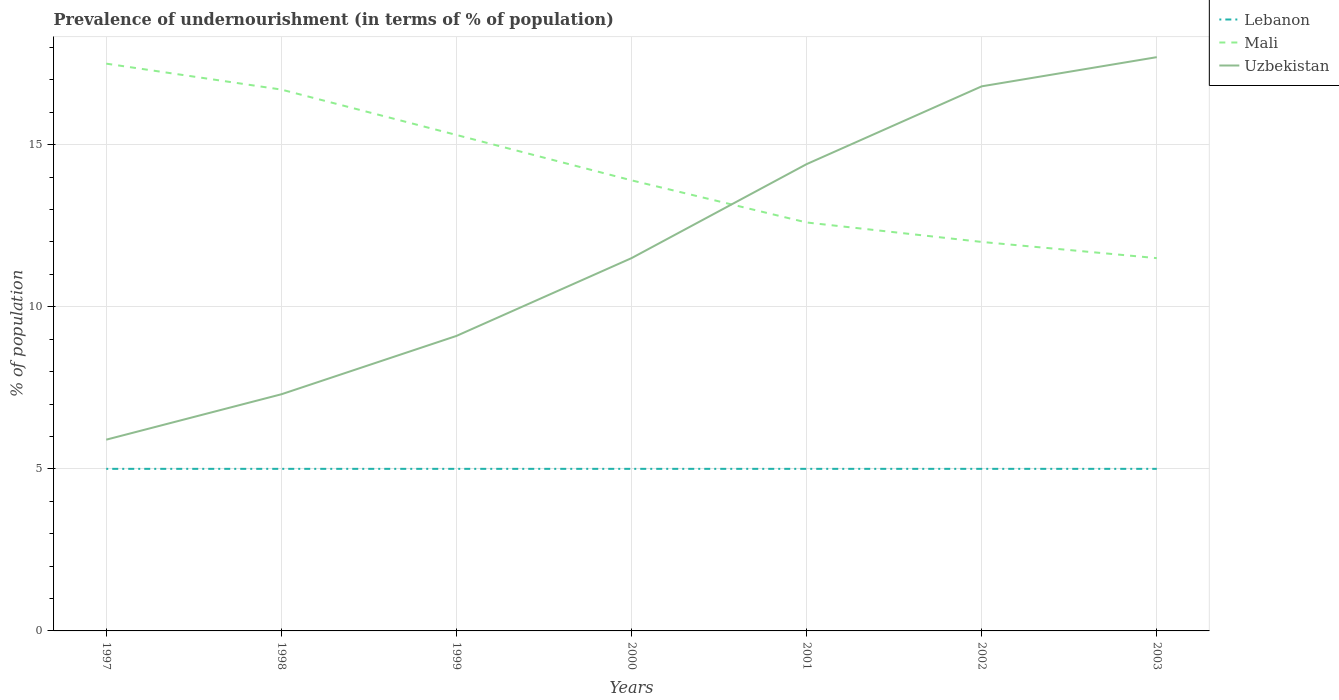How many different coloured lines are there?
Give a very brief answer. 3. Does the line corresponding to Uzbekistan intersect with the line corresponding to Mali?
Keep it short and to the point. Yes. Across all years, what is the maximum percentage of undernourished population in Uzbekistan?
Provide a short and direct response. 5.9. In which year was the percentage of undernourished population in Uzbekistan maximum?
Give a very brief answer. 1997. What is the total percentage of undernourished population in Mali in the graph?
Your answer should be compact. 2.7. Is the percentage of undernourished population in Mali strictly greater than the percentage of undernourished population in Uzbekistan over the years?
Give a very brief answer. No. How many lines are there?
Ensure brevity in your answer.  3. What is the difference between two consecutive major ticks on the Y-axis?
Offer a terse response. 5. Does the graph contain any zero values?
Offer a very short reply. No. How many legend labels are there?
Your answer should be very brief. 3. How are the legend labels stacked?
Provide a short and direct response. Vertical. What is the title of the graph?
Offer a terse response. Prevalence of undernourishment (in terms of % of population). Does "Cyprus" appear as one of the legend labels in the graph?
Offer a very short reply. No. What is the label or title of the Y-axis?
Offer a very short reply. % of population. What is the % of population of Mali in 1997?
Your response must be concise. 17.5. What is the % of population in Uzbekistan in 1997?
Offer a terse response. 5.9. What is the % of population of Mali in 1998?
Your answer should be very brief. 16.7. What is the % of population in Uzbekistan in 1998?
Keep it short and to the point. 7.3. What is the % of population in Lebanon in 1999?
Offer a very short reply. 5. What is the % of population of Mali in 1999?
Provide a short and direct response. 15.3. What is the % of population in Uzbekistan in 1999?
Offer a very short reply. 9.1. What is the % of population of Lebanon in 2000?
Provide a short and direct response. 5. What is the % of population of Mali in 2000?
Ensure brevity in your answer.  13.9. What is the % of population of Lebanon in 2001?
Your answer should be compact. 5. What is the % of population of Uzbekistan in 2001?
Your response must be concise. 14.4. What is the % of population in Uzbekistan in 2002?
Give a very brief answer. 16.8. What is the % of population of Lebanon in 2003?
Ensure brevity in your answer.  5. What is the % of population in Mali in 2003?
Offer a terse response. 11.5. What is the % of population in Uzbekistan in 2003?
Offer a very short reply. 17.7. Across all years, what is the maximum % of population in Lebanon?
Provide a succinct answer. 5. Across all years, what is the maximum % of population of Mali?
Provide a succinct answer. 17.5. Across all years, what is the minimum % of population of Lebanon?
Offer a very short reply. 5. Across all years, what is the minimum % of population in Mali?
Offer a very short reply. 11.5. Across all years, what is the minimum % of population of Uzbekistan?
Keep it short and to the point. 5.9. What is the total % of population of Mali in the graph?
Your response must be concise. 99.5. What is the total % of population of Uzbekistan in the graph?
Offer a terse response. 82.7. What is the difference between the % of population of Mali in 1997 and that in 1998?
Your answer should be compact. 0.8. What is the difference between the % of population in Mali in 1997 and that in 1999?
Your response must be concise. 2.2. What is the difference between the % of population in Uzbekistan in 1997 and that in 1999?
Your answer should be compact. -3.2. What is the difference between the % of population in Uzbekistan in 1997 and that in 2000?
Provide a succinct answer. -5.6. What is the difference between the % of population of Lebanon in 1997 and that in 2001?
Provide a short and direct response. 0. What is the difference between the % of population of Mali in 1997 and that in 2001?
Offer a terse response. 4.9. What is the difference between the % of population of Uzbekistan in 1997 and that in 2001?
Offer a terse response. -8.5. What is the difference between the % of population in Lebanon in 1997 and that in 2002?
Offer a very short reply. 0. What is the difference between the % of population of Mali in 1997 and that in 2002?
Ensure brevity in your answer.  5.5. What is the difference between the % of population of Uzbekistan in 1997 and that in 2002?
Provide a succinct answer. -10.9. What is the difference between the % of population in Lebanon in 1997 and that in 2003?
Your answer should be compact. 0. What is the difference between the % of population of Mali in 1997 and that in 2003?
Your answer should be very brief. 6. What is the difference between the % of population of Uzbekistan in 1997 and that in 2003?
Your response must be concise. -11.8. What is the difference between the % of population of Lebanon in 1998 and that in 1999?
Make the answer very short. 0. What is the difference between the % of population in Lebanon in 1998 and that in 2001?
Give a very brief answer. 0. What is the difference between the % of population of Mali in 1998 and that in 2001?
Your answer should be very brief. 4.1. What is the difference between the % of population in Mali in 1999 and that in 2000?
Your answer should be very brief. 1.4. What is the difference between the % of population of Uzbekistan in 1999 and that in 2000?
Offer a very short reply. -2.4. What is the difference between the % of population in Mali in 1999 and that in 2002?
Keep it short and to the point. 3.3. What is the difference between the % of population of Uzbekistan in 1999 and that in 2002?
Provide a short and direct response. -7.7. What is the difference between the % of population in Mali in 2000 and that in 2001?
Your answer should be very brief. 1.3. What is the difference between the % of population of Uzbekistan in 2000 and that in 2001?
Keep it short and to the point. -2.9. What is the difference between the % of population of Lebanon in 2000 and that in 2002?
Keep it short and to the point. 0. What is the difference between the % of population in Mali in 2000 and that in 2002?
Make the answer very short. 1.9. What is the difference between the % of population of Uzbekistan in 2000 and that in 2002?
Your answer should be compact. -5.3. What is the difference between the % of population in Mali in 2001 and that in 2002?
Provide a short and direct response. 0.6. What is the difference between the % of population of Lebanon in 2001 and that in 2003?
Give a very brief answer. 0. What is the difference between the % of population in Uzbekistan in 2001 and that in 2003?
Offer a terse response. -3.3. What is the difference between the % of population of Lebanon in 2002 and that in 2003?
Make the answer very short. 0. What is the difference between the % of population of Mali in 2002 and that in 2003?
Your answer should be compact. 0.5. What is the difference between the % of population of Uzbekistan in 2002 and that in 2003?
Your answer should be compact. -0.9. What is the difference between the % of population of Lebanon in 1997 and the % of population of Mali in 1998?
Keep it short and to the point. -11.7. What is the difference between the % of population in Mali in 1997 and the % of population in Uzbekistan in 1998?
Your response must be concise. 10.2. What is the difference between the % of population in Lebanon in 1997 and the % of population in Mali in 1999?
Offer a terse response. -10.3. What is the difference between the % of population in Mali in 1997 and the % of population in Uzbekistan in 2000?
Your answer should be compact. 6. What is the difference between the % of population in Lebanon in 1997 and the % of population in Mali in 2003?
Your response must be concise. -6.5. What is the difference between the % of population of Mali in 1997 and the % of population of Uzbekistan in 2003?
Keep it short and to the point. -0.2. What is the difference between the % of population in Lebanon in 1998 and the % of population in Mali in 1999?
Your answer should be compact. -10.3. What is the difference between the % of population in Mali in 1998 and the % of population in Uzbekistan in 1999?
Make the answer very short. 7.6. What is the difference between the % of population of Lebanon in 1998 and the % of population of Uzbekistan in 2001?
Offer a terse response. -9.4. What is the difference between the % of population in Lebanon in 1998 and the % of population in Uzbekistan in 2002?
Ensure brevity in your answer.  -11.8. What is the difference between the % of population of Lebanon in 1998 and the % of population of Uzbekistan in 2003?
Keep it short and to the point. -12.7. What is the difference between the % of population in Mali in 1998 and the % of population in Uzbekistan in 2003?
Keep it short and to the point. -1. What is the difference between the % of population in Lebanon in 1999 and the % of population in Uzbekistan in 2000?
Offer a terse response. -6.5. What is the difference between the % of population of Mali in 1999 and the % of population of Uzbekistan in 2000?
Your response must be concise. 3.8. What is the difference between the % of population in Lebanon in 1999 and the % of population in Mali in 2001?
Provide a succinct answer. -7.6. What is the difference between the % of population in Lebanon in 1999 and the % of population in Uzbekistan in 2001?
Provide a succinct answer. -9.4. What is the difference between the % of population in Mali in 1999 and the % of population in Uzbekistan in 2001?
Provide a short and direct response. 0.9. What is the difference between the % of population in Lebanon in 1999 and the % of population in Mali in 2002?
Make the answer very short. -7. What is the difference between the % of population in Lebanon in 1999 and the % of population in Uzbekistan in 2002?
Provide a short and direct response. -11.8. What is the difference between the % of population of Lebanon in 1999 and the % of population of Mali in 2003?
Ensure brevity in your answer.  -6.5. What is the difference between the % of population in Lebanon in 1999 and the % of population in Uzbekistan in 2003?
Provide a short and direct response. -12.7. What is the difference between the % of population in Mali in 1999 and the % of population in Uzbekistan in 2003?
Offer a terse response. -2.4. What is the difference between the % of population of Lebanon in 2000 and the % of population of Mali in 2001?
Keep it short and to the point. -7.6. What is the difference between the % of population in Mali in 2000 and the % of population in Uzbekistan in 2002?
Keep it short and to the point. -2.9. What is the difference between the % of population in Lebanon in 2000 and the % of population in Uzbekistan in 2003?
Ensure brevity in your answer.  -12.7. What is the difference between the % of population in Lebanon in 2001 and the % of population in Mali in 2002?
Provide a short and direct response. -7. What is the difference between the % of population of Lebanon in 2001 and the % of population of Uzbekistan in 2002?
Offer a very short reply. -11.8. What is the difference between the % of population in Lebanon in 2001 and the % of population in Mali in 2003?
Your response must be concise. -6.5. What is the difference between the % of population in Lebanon in 2001 and the % of population in Uzbekistan in 2003?
Ensure brevity in your answer.  -12.7. What is the difference between the % of population in Lebanon in 2002 and the % of population in Mali in 2003?
Ensure brevity in your answer.  -6.5. What is the average % of population of Mali per year?
Keep it short and to the point. 14.21. What is the average % of population of Uzbekistan per year?
Make the answer very short. 11.81. In the year 1997, what is the difference between the % of population of Lebanon and % of population of Mali?
Keep it short and to the point. -12.5. In the year 1997, what is the difference between the % of population in Lebanon and % of population in Uzbekistan?
Provide a succinct answer. -0.9. In the year 1998, what is the difference between the % of population of Lebanon and % of population of Uzbekistan?
Your response must be concise. -2.3. In the year 1998, what is the difference between the % of population of Mali and % of population of Uzbekistan?
Provide a succinct answer. 9.4. In the year 1999, what is the difference between the % of population of Lebanon and % of population of Mali?
Offer a very short reply. -10.3. In the year 1999, what is the difference between the % of population of Lebanon and % of population of Uzbekistan?
Ensure brevity in your answer.  -4.1. In the year 1999, what is the difference between the % of population of Mali and % of population of Uzbekistan?
Offer a terse response. 6.2. In the year 2000, what is the difference between the % of population of Mali and % of population of Uzbekistan?
Provide a succinct answer. 2.4. In the year 2001, what is the difference between the % of population in Lebanon and % of population in Uzbekistan?
Provide a short and direct response. -9.4. In the year 2001, what is the difference between the % of population in Mali and % of population in Uzbekistan?
Your answer should be compact. -1.8. In the year 2002, what is the difference between the % of population of Lebanon and % of population of Mali?
Give a very brief answer. -7. In the year 2002, what is the difference between the % of population of Mali and % of population of Uzbekistan?
Make the answer very short. -4.8. In the year 2003, what is the difference between the % of population of Mali and % of population of Uzbekistan?
Your answer should be very brief. -6.2. What is the ratio of the % of population in Mali in 1997 to that in 1998?
Your response must be concise. 1.05. What is the ratio of the % of population in Uzbekistan in 1997 to that in 1998?
Your response must be concise. 0.81. What is the ratio of the % of population in Lebanon in 1997 to that in 1999?
Ensure brevity in your answer.  1. What is the ratio of the % of population in Mali in 1997 to that in 1999?
Offer a very short reply. 1.14. What is the ratio of the % of population of Uzbekistan in 1997 to that in 1999?
Provide a short and direct response. 0.65. What is the ratio of the % of population of Mali in 1997 to that in 2000?
Ensure brevity in your answer.  1.26. What is the ratio of the % of population in Uzbekistan in 1997 to that in 2000?
Offer a very short reply. 0.51. What is the ratio of the % of population in Mali in 1997 to that in 2001?
Your answer should be compact. 1.39. What is the ratio of the % of population of Uzbekistan in 1997 to that in 2001?
Provide a short and direct response. 0.41. What is the ratio of the % of population in Lebanon in 1997 to that in 2002?
Ensure brevity in your answer.  1. What is the ratio of the % of population of Mali in 1997 to that in 2002?
Offer a very short reply. 1.46. What is the ratio of the % of population in Uzbekistan in 1997 to that in 2002?
Provide a succinct answer. 0.35. What is the ratio of the % of population in Lebanon in 1997 to that in 2003?
Offer a very short reply. 1. What is the ratio of the % of population of Mali in 1997 to that in 2003?
Provide a succinct answer. 1.52. What is the ratio of the % of population of Uzbekistan in 1997 to that in 2003?
Offer a terse response. 0.33. What is the ratio of the % of population in Lebanon in 1998 to that in 1999?
Ensure brevity in your answer.  1. What is the ratio of the % of population of Mali in 1998 to that in 1999?
Offer a terse response. 1.09. What is the ratio of the % of population in Uzbekistan in 1998 to that in 1999?
Make the answer very short. 0.8. What is the ratio of the % of population of Mali in 1998 to that in 2000?
Provide a succinct answer. 1.2. What is the ratio of the % of population of Uzbekistan in 1998 to that in 2000?
Give a very brief answer. 0.63. What is the ratio of the % of population in Mali in 1998 to that in 2001?
Provide a short and direct response. 1.33. What is the ratio of the % of population in Uzbekistan in 1998 to that in 2001?
Your response must be concise. 0.51. What is the ratio of the % of population in Lebanon in 1998 to that in 2002?
Provide a short and direct response. 1. What is the ratio of the % of population in Mali in 1998 to that in 2002?
Offer a very short reply. 1.39. What is the ratio of the % of population of Uzbekistan in 1998 to that in 2002?
Make the answer very short. 0.43. What is the ratio of the % of population of Lebanon in 1998 to that in 2003?
Give a very brief answer. 1. What is the ratio of the % of population in Mali in 1998 to that in 2003?
Give a very brief answer. 1.45. What is the ratio of the % of population of Uzbekistan in 1998 to that in 2003?
Provide a succinct answer. 0.41. What is the ratio of the % of population of Lebanon in 1999 to that in 2000?
Keep it short and to the point. 1. What is the ratio of the % of population in Mali in 1999 to that in 2000?
Keep it short and to the point. 1.1. What is the ratio of the % of population in Uzbekistan in 1999 to that in 2000?
Provide a succinct answer. 0.79. What is the ratio of the % of population in Lebanon in 1999 to that in 2001?
Your answer should be compact. 1. What is the ratio of the % of population of Mali in 1999 to that in 2001?
Provide a short and direct response. 1.21. What is the ratio of the % of population in Uzbekistan in 1999 to that in 2001?
Provide a succinct answer. 0.63. What is the ratio of the % of population of Lebanon in 1999 to that in 2002?
Your response must be concise. 1. What is the ratio of the % of population in Mali in 1999 to that in 2002?
Ensure brevity in your answer.  1.27. What is the ratio of the % of population in Uzbekistan in 1999 to that in 2002?
Make the answer very short. 0.54. What is the ratio of the % of population of Mali in 1999 to that in 2003?
Ensure brevity in your answer.  1.33. What is the ratio of the % of population of Uzbekistan in 1999 to that in 2003?
Provide a succinct answer. 0.51. What is the ratio of the % of population of Mali in 2000 to that in 2001?
Your answer should be very brief. 1.1. What is the ratio of the % of population in Uzbekistan in 2000 to that in 2001?
Provide a short and direct response. 0.8. What is the ratio of the % of population of Lebanon in 2000 to that in 2002?
Provide a short and direct response. 1. What is the ratio of the % of population in Mali in 2000 to that in 2002?
Offer a very short reply. 1.16. What is the ratio of the % of population of Uzbekistan in 2000 to that in 2002?
Give a very brief answer. 0.68. What is the ratio of the % of population of Mali in 2000 to that in 2003?
Provide a short and direct response. 1.21. What is the ratio of the % of population of Uzbekistan in 2000 to that in 2003?
Your response must be concise. 0.65. What is the ratio of the % of population in Lebanon in 2001 to that in 2002?
Your response must be concise. 1. What is the ratio of the % of population in Mali in 2001 to that in 2002?
Provide a succinct answer. 1.05. What is the ratio of the % of population in Uzbekistan in 2001 to that in 2002?
Give a very brief answer. 0.86. What is the ratio of the % of population of Lebanon in 2001 to that in 2003?
Give a very brief answer. 1. What is the ratio of the % of population in Mali in 2001 to that in 2003?
Provide a succinct answer. 1.1. What is the ratio of the % of population in Uzbekistan in 2001 to that in 2003?
Keep it short and to the point. 0.81. What is the ratio of the % of population of Lebanon in 2002 to that in 2003?
Give a very brief answer. 1. What is the ratio of the % of population of Mali in 2002 to that in 2003?
Give a very brief answer. 1.04. What is the ratio of the % of population in Uzbekistan in 2002 to that in 2003?
Your answer should be very brief. 0.95. What is the difference between the highest and the lowest % of population in Uzbekistan?
Your answer should be compact. 11.8. 